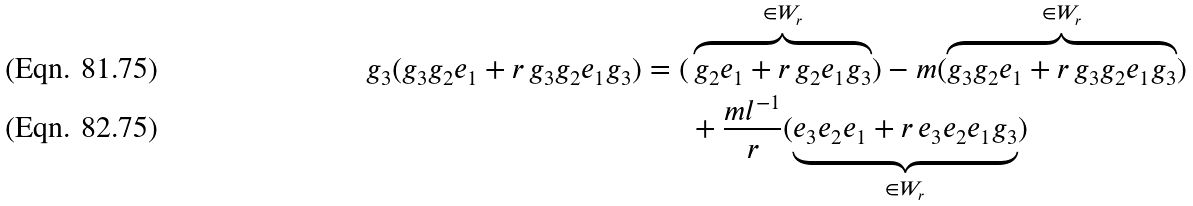<formula> <loc_0><loc_0><loc_500><loc_500>g _ { 3 } ( g _ { 3 } g _ { 2 } e _ { 1 } + r \, g _ { 3 } g _ { 2 } e _ { 1 } g _ { 3 } ) = ( & \overbrace { g _ { 2 } e _ { 1 } + r \, g _ { 2 } e _ { 1 } g _ { 3 } } ^ { \in W _ { r } } ) - m ( \overbrace { g _ { 3 } g _ { 2 } e _ { 1 } + r \, g _ { 3 } g _ { 2 } e _ { 1 } g _ { 3 } } ^ { \in W _ { r } } ) \\ & + \frac { m l ^ { - 1 } } { r } ( \underbrace { e _ { 3 } e _ { 2 } e _ { 1 } + r \, e _ { 3 } e _ { 2 } e _ { 1 } g _ { 3 } } _ { \in W _ { r } } )</formula> 